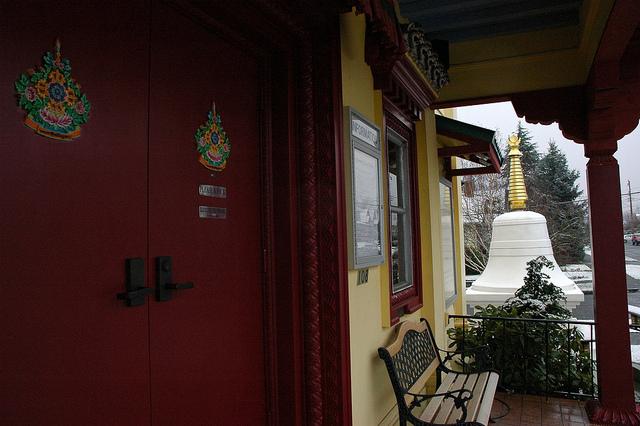Are there any reflections visible?
Write a very short answer. No. What color are the flowers in the room?
Write a very short answer. Green. What are they on?
Concise answer only. Porch. Is there one door?
Short answer required. No. What is the color scheme of the photo?
Write a very short answer. Red. Is this in New York City?
Short answer required. No. The bench is made for how many people?
Quick response, please. 2. Is it night time outside?
Write a very short answer. No. Is anyone sitting on the bench?
Keep it brief. No. Where is the lampshade?
Answer briefly. Nowhere. 